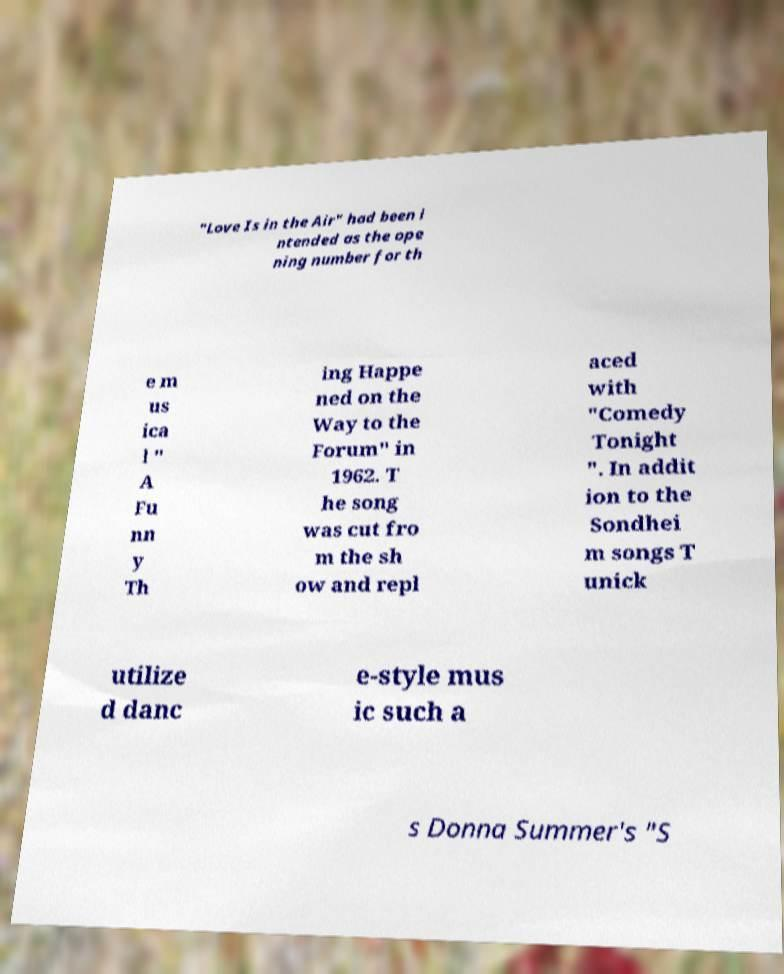Can you read and provide the text displayed in the image?This photo seems to have some interesting text. Can you extract and type it out for me? "Love Is in the Air" had been i ntended as the ope ning number for th e m us ica l " A Fu nn y Th ing Happe ned on the Way to the Forum" in 1962. T he song was cut fro m the sh ow and repl aced with "Comedy Tonight ". In addit ion to the Sondhei m songs T unick utilize d danc e-style mus ic such a s Donna Summer's "S 